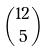Convert formula to latex. <formula><loc_0><loc_0><loc_500><loc_500>\binom { 1 2 } { 5 }</formula> 